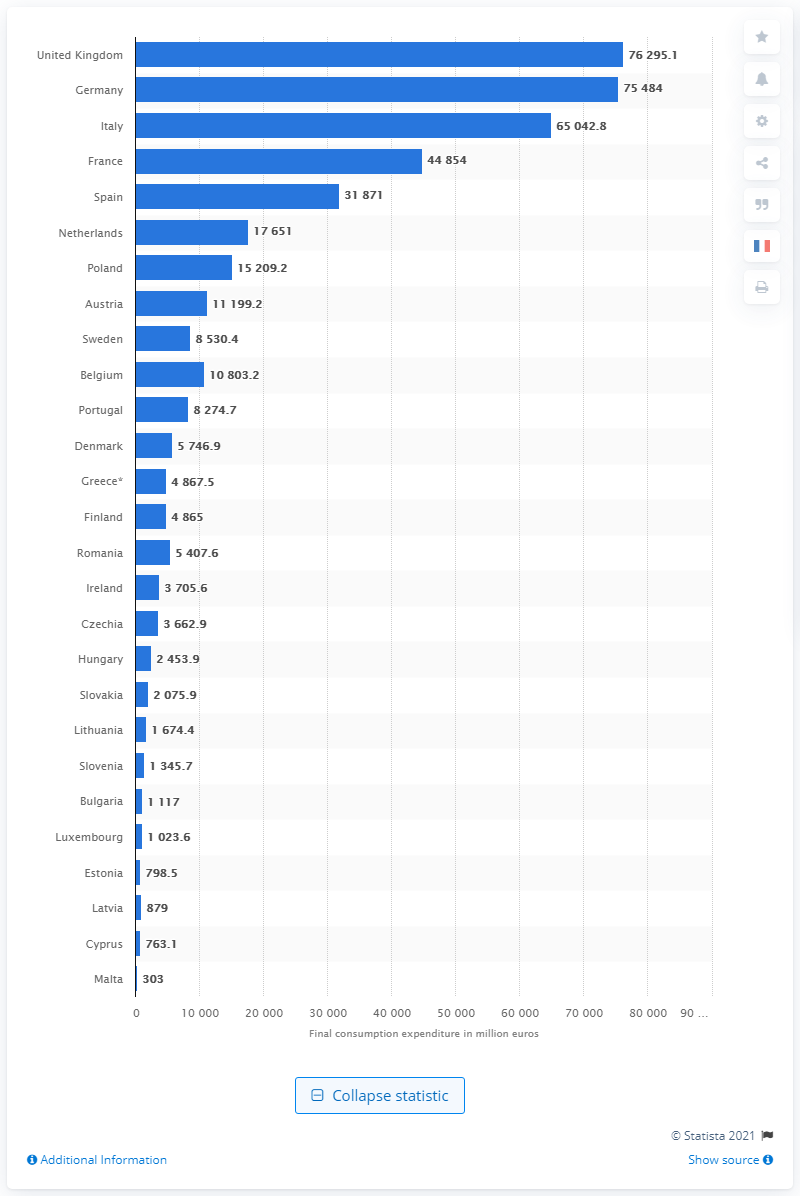List a handful of essential elements in this visual. In the United Kingdom in 2018, households spent an estimated 76,295.1 pounds on clothing and footwear. 